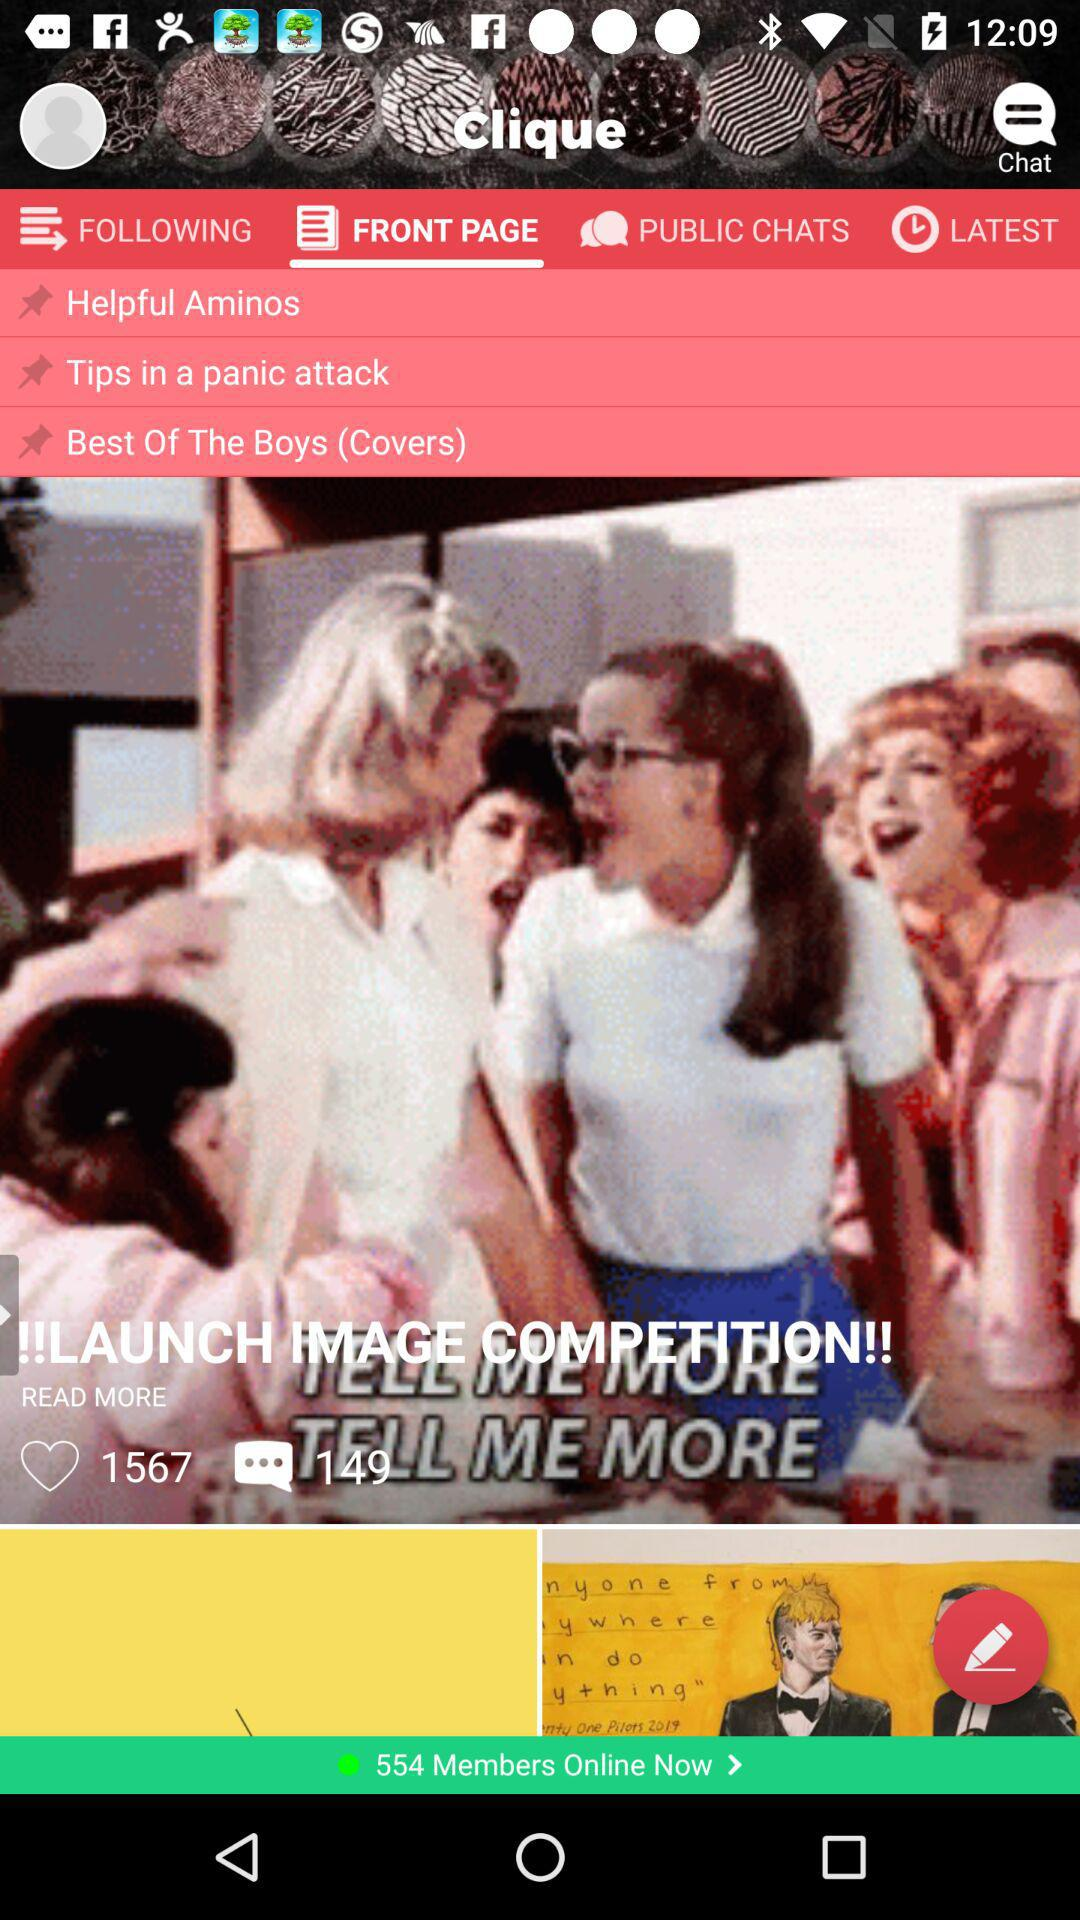How many members are online now? There are 554 online members. 